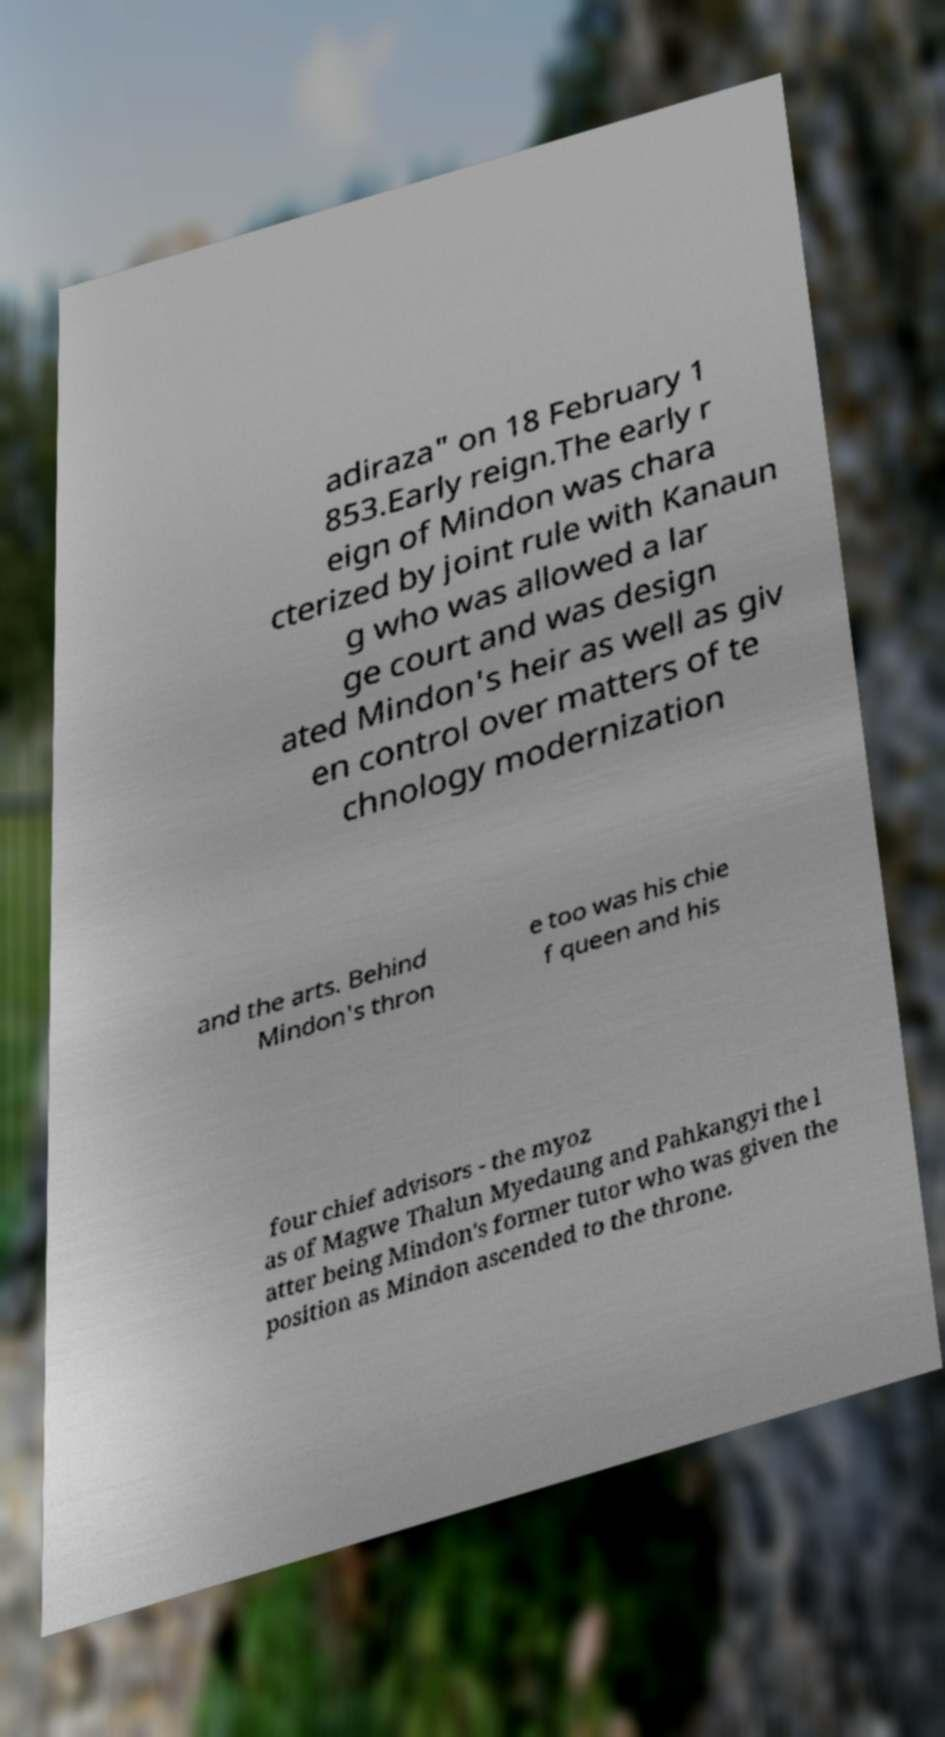Can you accurately transcribe the text from the provided image for me? adiraza" on 18 February 1 853.Early reign.The early r eign of Mindon was chara cterized by joint rule with Kanaun g who was allowed a lar ge court and was design ated Mindon's heir as well as giv en control over matters of te chnology modernization and the arts. Behind Mindon's thron e too was his chie f queen and his four chief advisors - the myoz as of Magwe Thalun Myedaung and Pahkangyi the l atter being Mindon's former tutor who was given the position as Mindon ascended to the throne. 